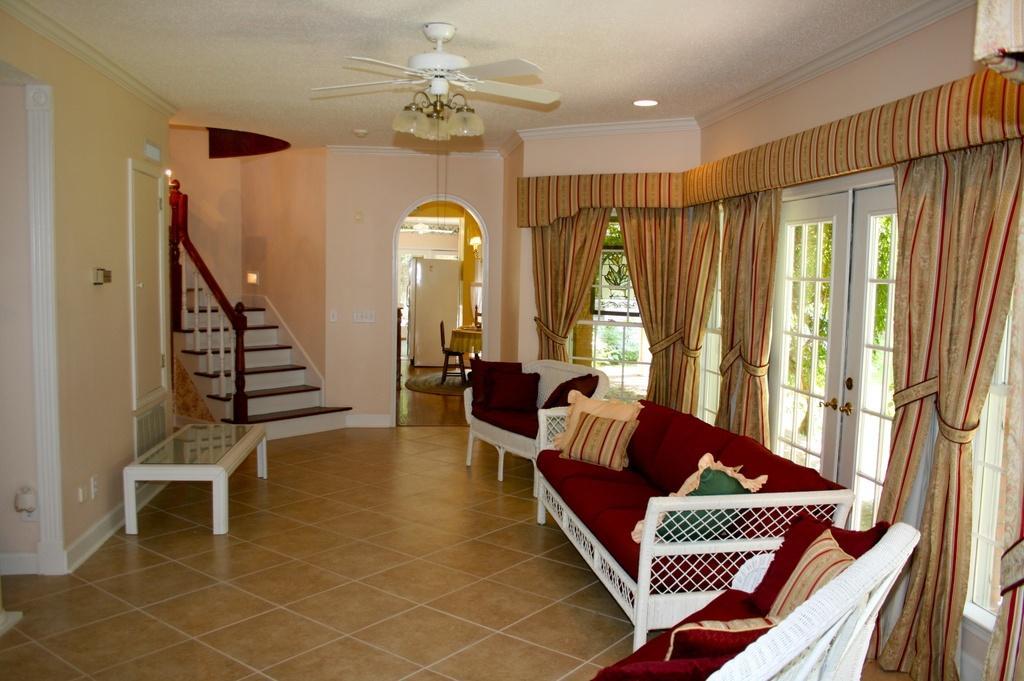How would you summarize this image in a sentence or two? In this image I can see the inside view of the house. On the left side there is a small table. On the right side there is a window and here I can see the curtains. On the top of this image there is a fan. Here I can see the stairs. And the outside of this house I can see some trees. Here I can see the sofa and pillows on it. And in the center of the image I can see a refrigerator and a mat on the floor. 